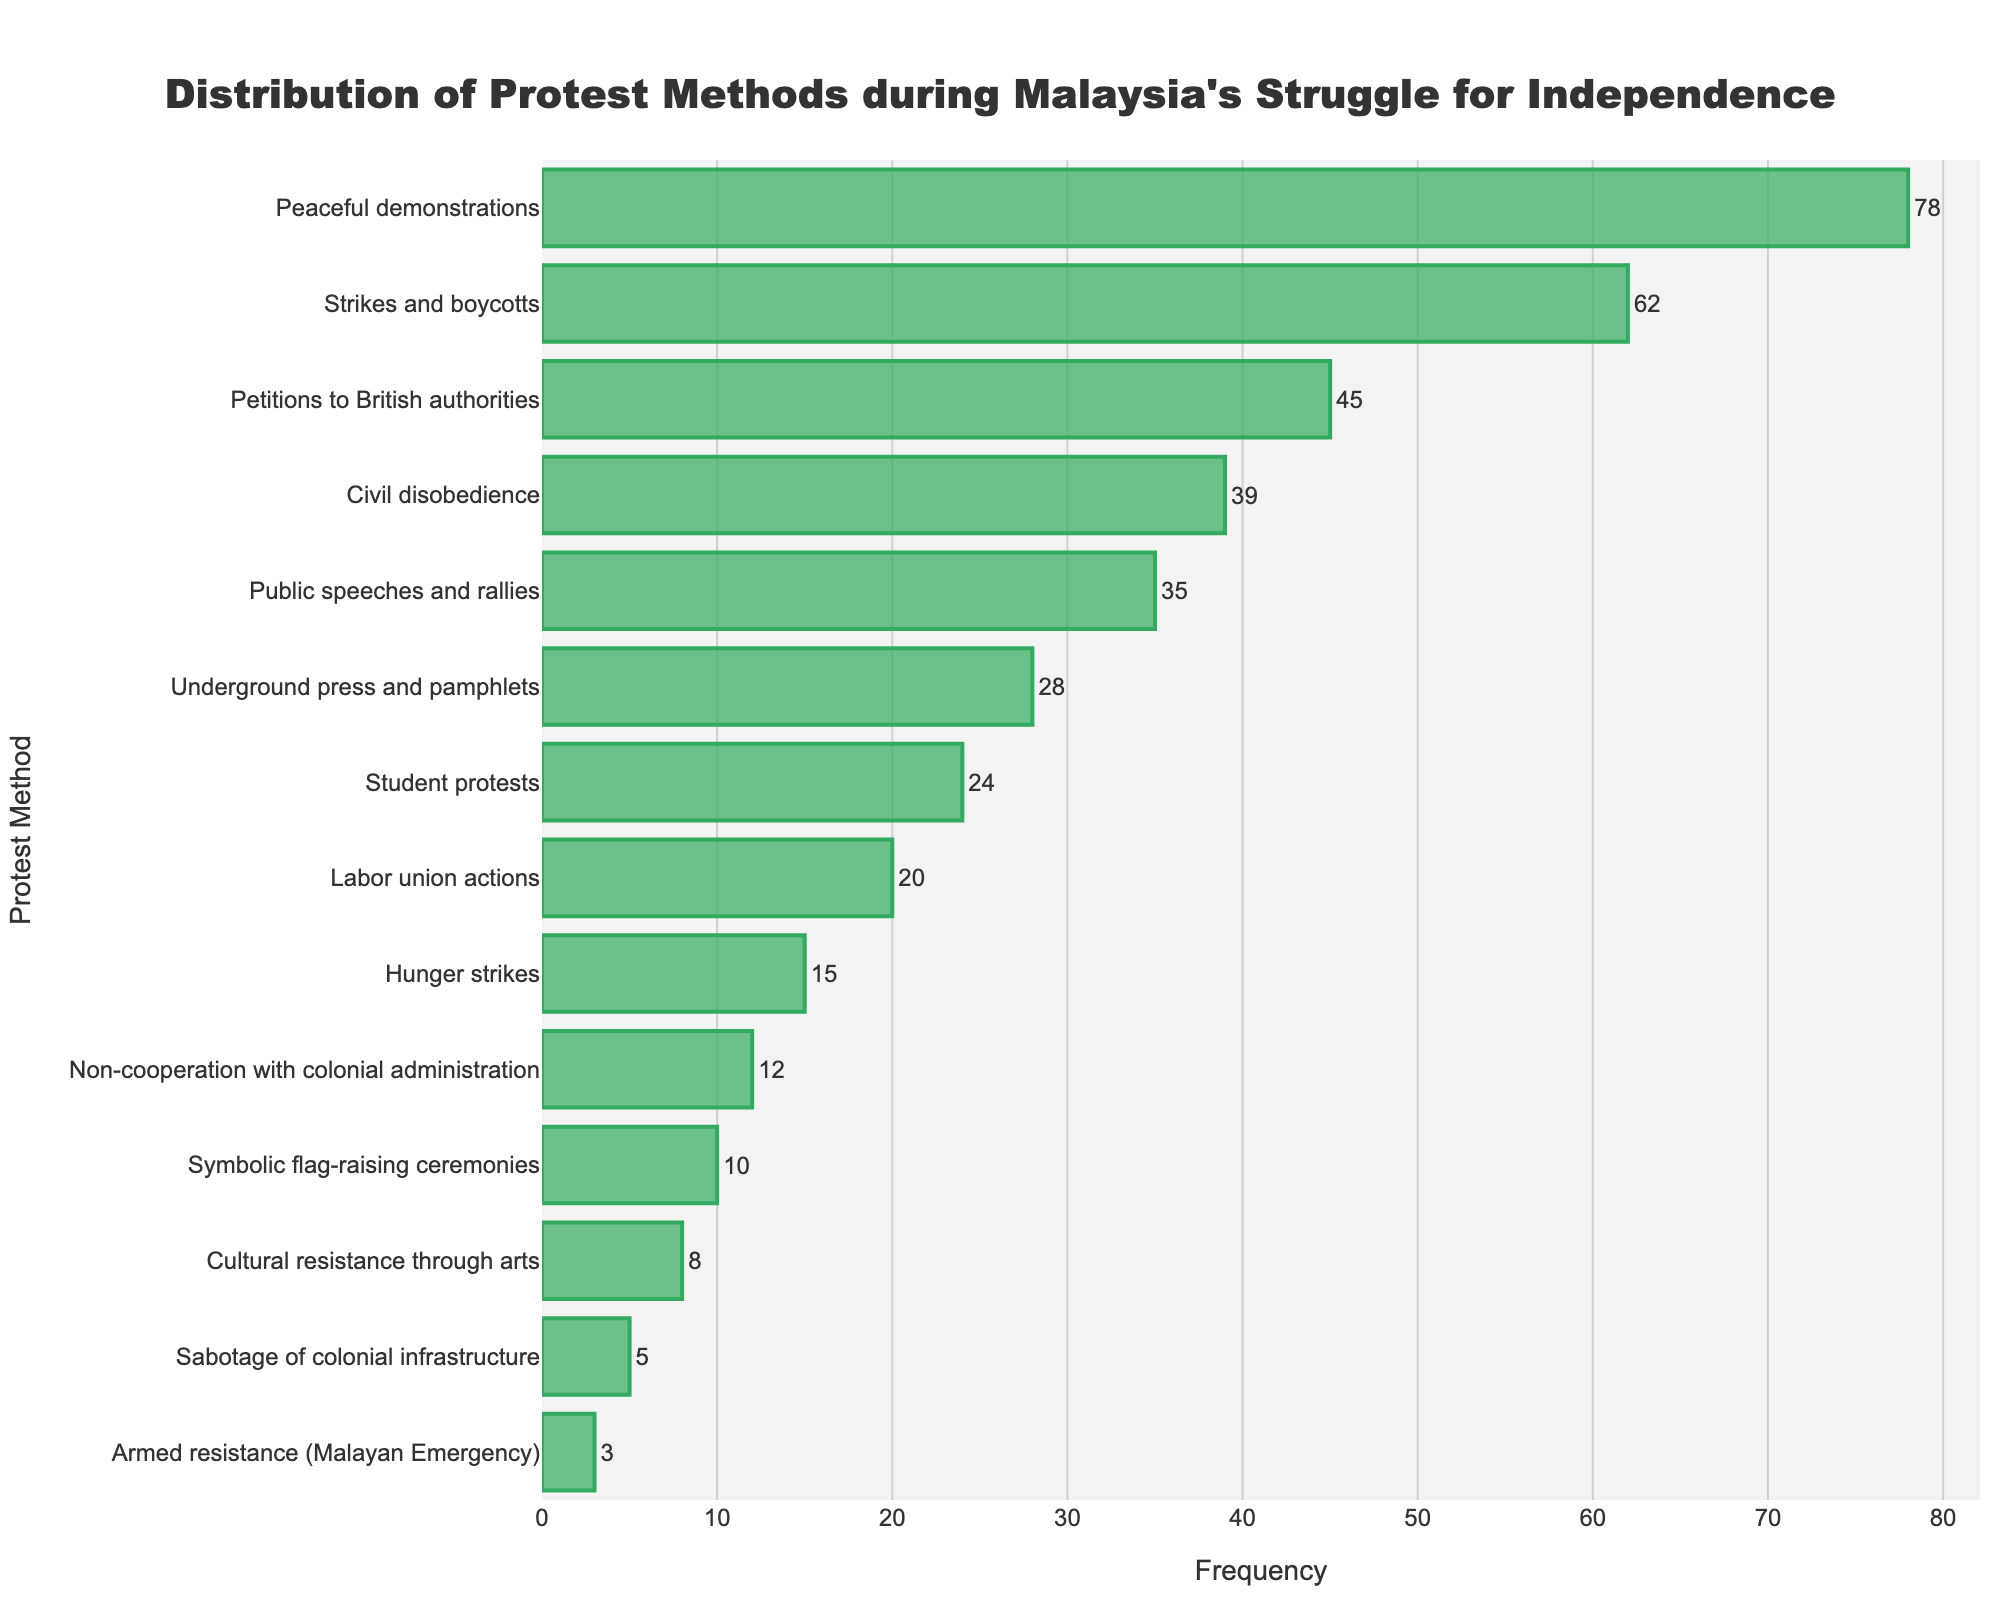Which protest method was used most frequently? The bar corresponding to "Peaceful demonstrations" has the greatest length, indicating it is the most frequently used protest method.
Answer: Peaceful demonstrations Which three protest methods were used least frequently? The bars corresponding to "Sabotage of colonial infrastructure," "Armed resistance (Malayan Emergency)," and "Cultural resistance through arts" are the shortest, indicating these methods were used least frequently.
Answer: Sabotage of colonial infrastructure, Armed resistance (Malayan Emergency), Cultural resistance through arts What is the combined frequency of "Petitions to British authorities" and "Public speeches and rallies"? To find the combined frequency, add the frequency of "Petitions to British authorities" (45) and "Public speeches and rallies" (35).
Answer: 80 How does the frequency of "Strikes and boycotts" compare to "Civil disobedience"? "Strikes and boycotts" has a bar that is longer than "Civil disobedience," indicating higher frequency. "Strikes and boycotts" have a frequency of 62, whereas "Civil disobedience" has a frequency of 39.
Answer: Strikes and boycotts are more frequent What is the frequency difference between "Student protests" and "Labor union actions"? Subtract the frequency of "Labor union actions" (20) from "Student protests" (24) to find the difference.
Answer: 4 Which two categories have frequencies that are within 5 units of each other? Inspecting the bars, "Student protests" (24) and "Labor union actions" (20) have frequencies that are within 5 units of each other.
Answer: Student protests, Labor union actions What percentage of the total protest methods does "Hunger strikes" represent? Sum all frequencies to get the total (78+62+45+39+35+28+24+20+15+12+10+8+5+3 = 384). Then, divide the frequency of "Hunger strikes" (15) by the total and multiply by 100. (15/384*100 ≈ 3.91%).
Answer: Approximately 3.91% Which method shows a frequency closest to the average frequency of all methods? Calculate the total frequency (384) and then find the average by dividing by the number of methods (14). 384 / 14 ≈ 27.43. "Underground press and pamphlets" with a frequency of 28 is closest to the average.
Answer: Underground press and pamphlets Are there more protest methods with frequencies above or below 20? Count the frequencies above 20 (7 methods) and below 20 (7 methods).
Answer: They are equal 